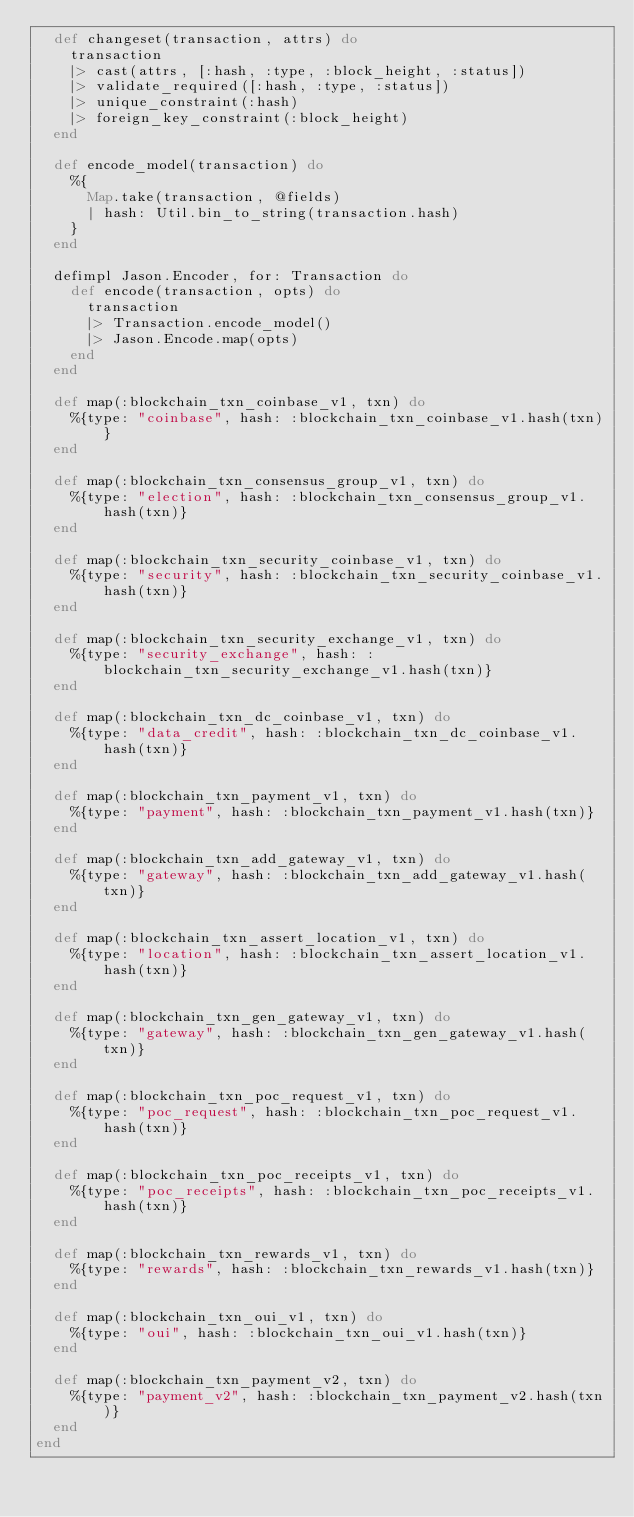Convert code to text. <code><loc_0><loc_0><loc_500><loc_500><_Elixir_>  def changeset(transaction, attrs) do
    transaction
    |> cast(attrs, [:hash, :type, :block_height, :status])
    |> validate_required([:hash, :type, :status])
    |> unique_constraint(:hash)
    |> foreign_key_constraint(:block_height)
  end

  def encode_model(transaction) do
    %{
      Map.take(transaction, @fields)
      | hash: Util.bin_to_string(transaction.hash)
    }
  end

  defimpl Jason.Encoder, for: Transaction do
    def encode(transaction, opts) do
      transaction
      |> Transaction.encode_model()
      |> Jason.Encode.map(opts)
    end
  end

  def map(:blockchain_txn_coinbase_v1, txn) do
    %{type: "coinbase", hash: :blockchain_txn_coinbase_v1.hash(txn)}
  end

  def map(:blockchain_txn_consensus_group_v1, txn) do
    %{type: "election", hash: :blockchain_txn_consensus_group_v1.hash(txn)}
  end

  def map(:blockchain_txn_security_coinbase_v1, txn) do
    %{type: "security", hash: :blockchain_txn_security_coinbase_v1.hash(txn)}
  end

  def map(:blockchain_txn_security_exchange_v1, txn) do
    %{type: "security_exchange", hash: :blockchain_txn_security_exchange_v1.hash(txn)}
  end

  def map(:blockchain_txn_dc_coinbase_v1, txn) do
    %{type: "data_credit", hash: :blockchain_txn_dc_coinbase_v1.hash(txn)}
  end

  def map(:blockchain_txn_payment_v1, txn) do
    %{type: "payment", hash: :blockchain_txn_payment_v1.hash(txn)}
  end

  def map(:blockchain_txn_add_gateway_v1, txn) do
    %{type: "gateway", hash: :blockchain_txn_add_gateway_v1.hash(txn)}
  end

  def map(:blockchain_txn_assert_location_v1, txn) do
    %{type: "location", hash: :blockchain_txn_assert_location_v1.hash(txn)}
  end

  def map(:blockchain_txn_gen_gateway_v1, txn) do
    %{type: "gateway", hash: :blockchain_txn_gen_gateway_v1.hash(txn)}
  end

  def map(:blockchain_txn_poc_request_v1, txn) do
    %{type: "poc_request", hash: :blockchain_txn_poc_request_v1.hash(txn)}
  end

  def map(:blockchain_txn_poc_receipts_v1, txn) do
    %{type: "poc_receipts", hash: :blockchain_txn_poc_receipts_v1.hash(txn)}
  end

  def map(:blockchain_txn_rewards_v1, txn) do
    %{type: "rewards", hash: :blockchain_txn_rewards_v1.hash(txn)}
  end

  def map(:blockchain_txn_oui_v1, txn) do
    %{type: "oui", hash: :blockchain_txn_oui_v1.hash(txn)}
  end

  def map(:blockchain_txn_payment_v2, txn) do
    %{type: "payment_v2", hash: :blockchain_txn_payment_v2.hash(txn)}
  end
end
</code> 